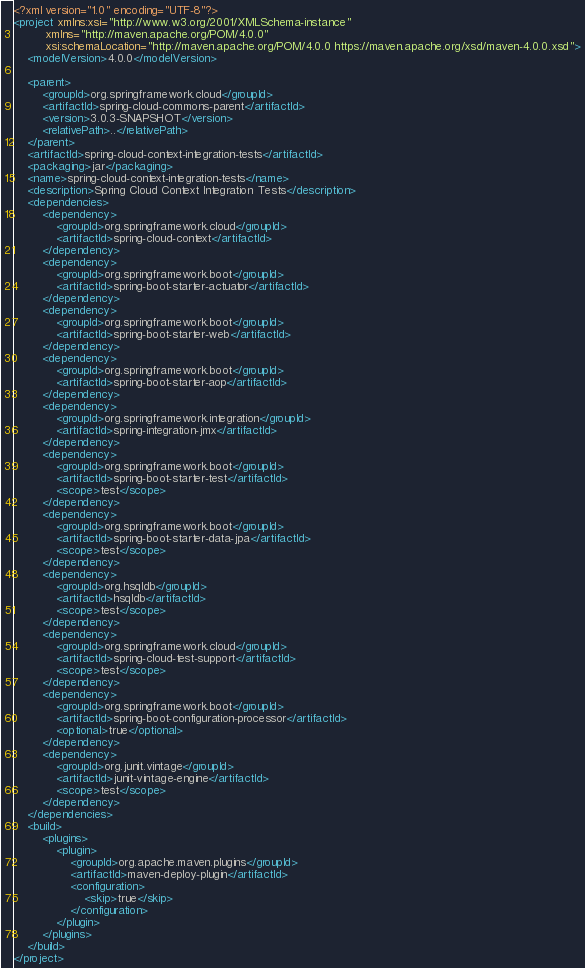<code> <loc_0><loc_0><loc_500><loc_500><_XML_><?xml version="1.0" encoding="UTF-8"?>
<project xmlns:xsi="http://www.w3.org/2001/XMLSchema-instance"
		 xmlns="http://maven.apache.org/POM/4.0.0"
		 xsi:schemaLocation="http://maven.apache.org/POM/4.0.0 https://maven.apache.org/xsd/maven-4.0.0.xsd">
	<modelVersion>4.0.0</modelVersion>

	<parent>
		<groupId>org.springframework.cloud</groupId>
		<artifactId>spring-cloud-commons-parent</artifactId>
		<version>3.0.3-SNAPSHOT</version>
		<relativePath>..</relativePath>
	</parent>
	<artifactId>spring-cloud-context-integration-tests</artifactId>
	<packaging>jar</packaging>
	<name>spring-cloud-context-integration-tests</name>
	<description>Spring Cloud Context Integration Tests</description>
	<dependencies>
		<dependency>
			<groupId>org.springframework.cloud</groupId>
			<artifactId>spring-cloud-context</artifactId>
		</dependency>
		<dependency>
			<groupId>org.springframework.boot</groupId>
			<artifactId>spring-boot-starter-actuator</artifactId>
		</dependency>
		<dependency>
			<groupId>org.springframework.boot</groupId>
			<artifactId>spring-boot-starter-web</artifactId>
		</dependency>
		<dependency>
			<groupId>org.springframework.boot</groupId>
			<artifactId>spring-boot-starter-aop</artifactId>
		</dependency>
		<dependency>
			<groupId>org.springframework.integration</groupId>
			<artifactId>spring-integration-jmx</artifactId>
		</dependency>
		<dependency>
			<groupId>org.springframework.boot</groupId>
			<artifactId>spring-boot-starter-test</artifactId>
			<scope>test</scope>
		</dependency>
		<dependency>
			<groupId>org.springframework.boot</groupId>
			<artifactId>spring-boot-starter-data-jpa</artifactId>
			<scope>test</scope>
		</dependency>
		<dependency>
			<groupId>org.hsqldb</groupId>
			<artifactId>hsqldb</artifactId>
			<scope>test</scope>
		</dependency>
		<dependency>
			<groupId>org.springframework.cloud</groupId>
			<artifactId>spring-cloud-test-support</artifactId>
			<scope>test</scope>
		</dependency>
		<dependency>
			<groupId>org.springframework.boot</groupId>
			<artifactId>spring-boot-configuration-processor</artifactId>
			<optional>true</optional>
		</dependency>
		<dependency>
			<groupId>org.junit.vintage</groupId>
			<artifactId>junit-vintage-engine</artifactId>
			<scope>test</scope>
		</dependency>
	</dependencies>
	<build>
		<plugins>
			<plugin>
				<groupId>org.apache.maven.plugins</groupId>
				<artifactId>maven-deploy-plugin</artifactId>
				<configuration>
					<skip>true</skip>
				</configuration>
			</plugin>
		</plugins>
	</build>
</project>
</code> 